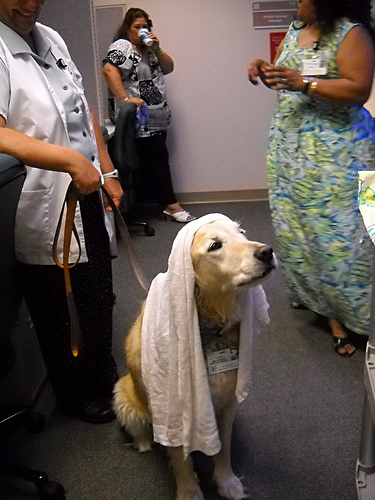<image>
Is the dog under the glass? No. The dog is not positioned under the glass. The vertical relationship between these objects is different. 